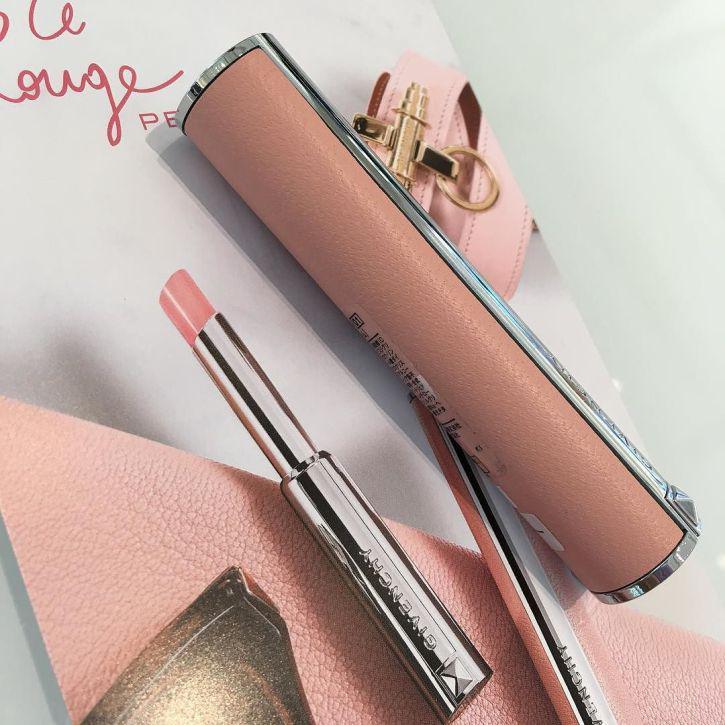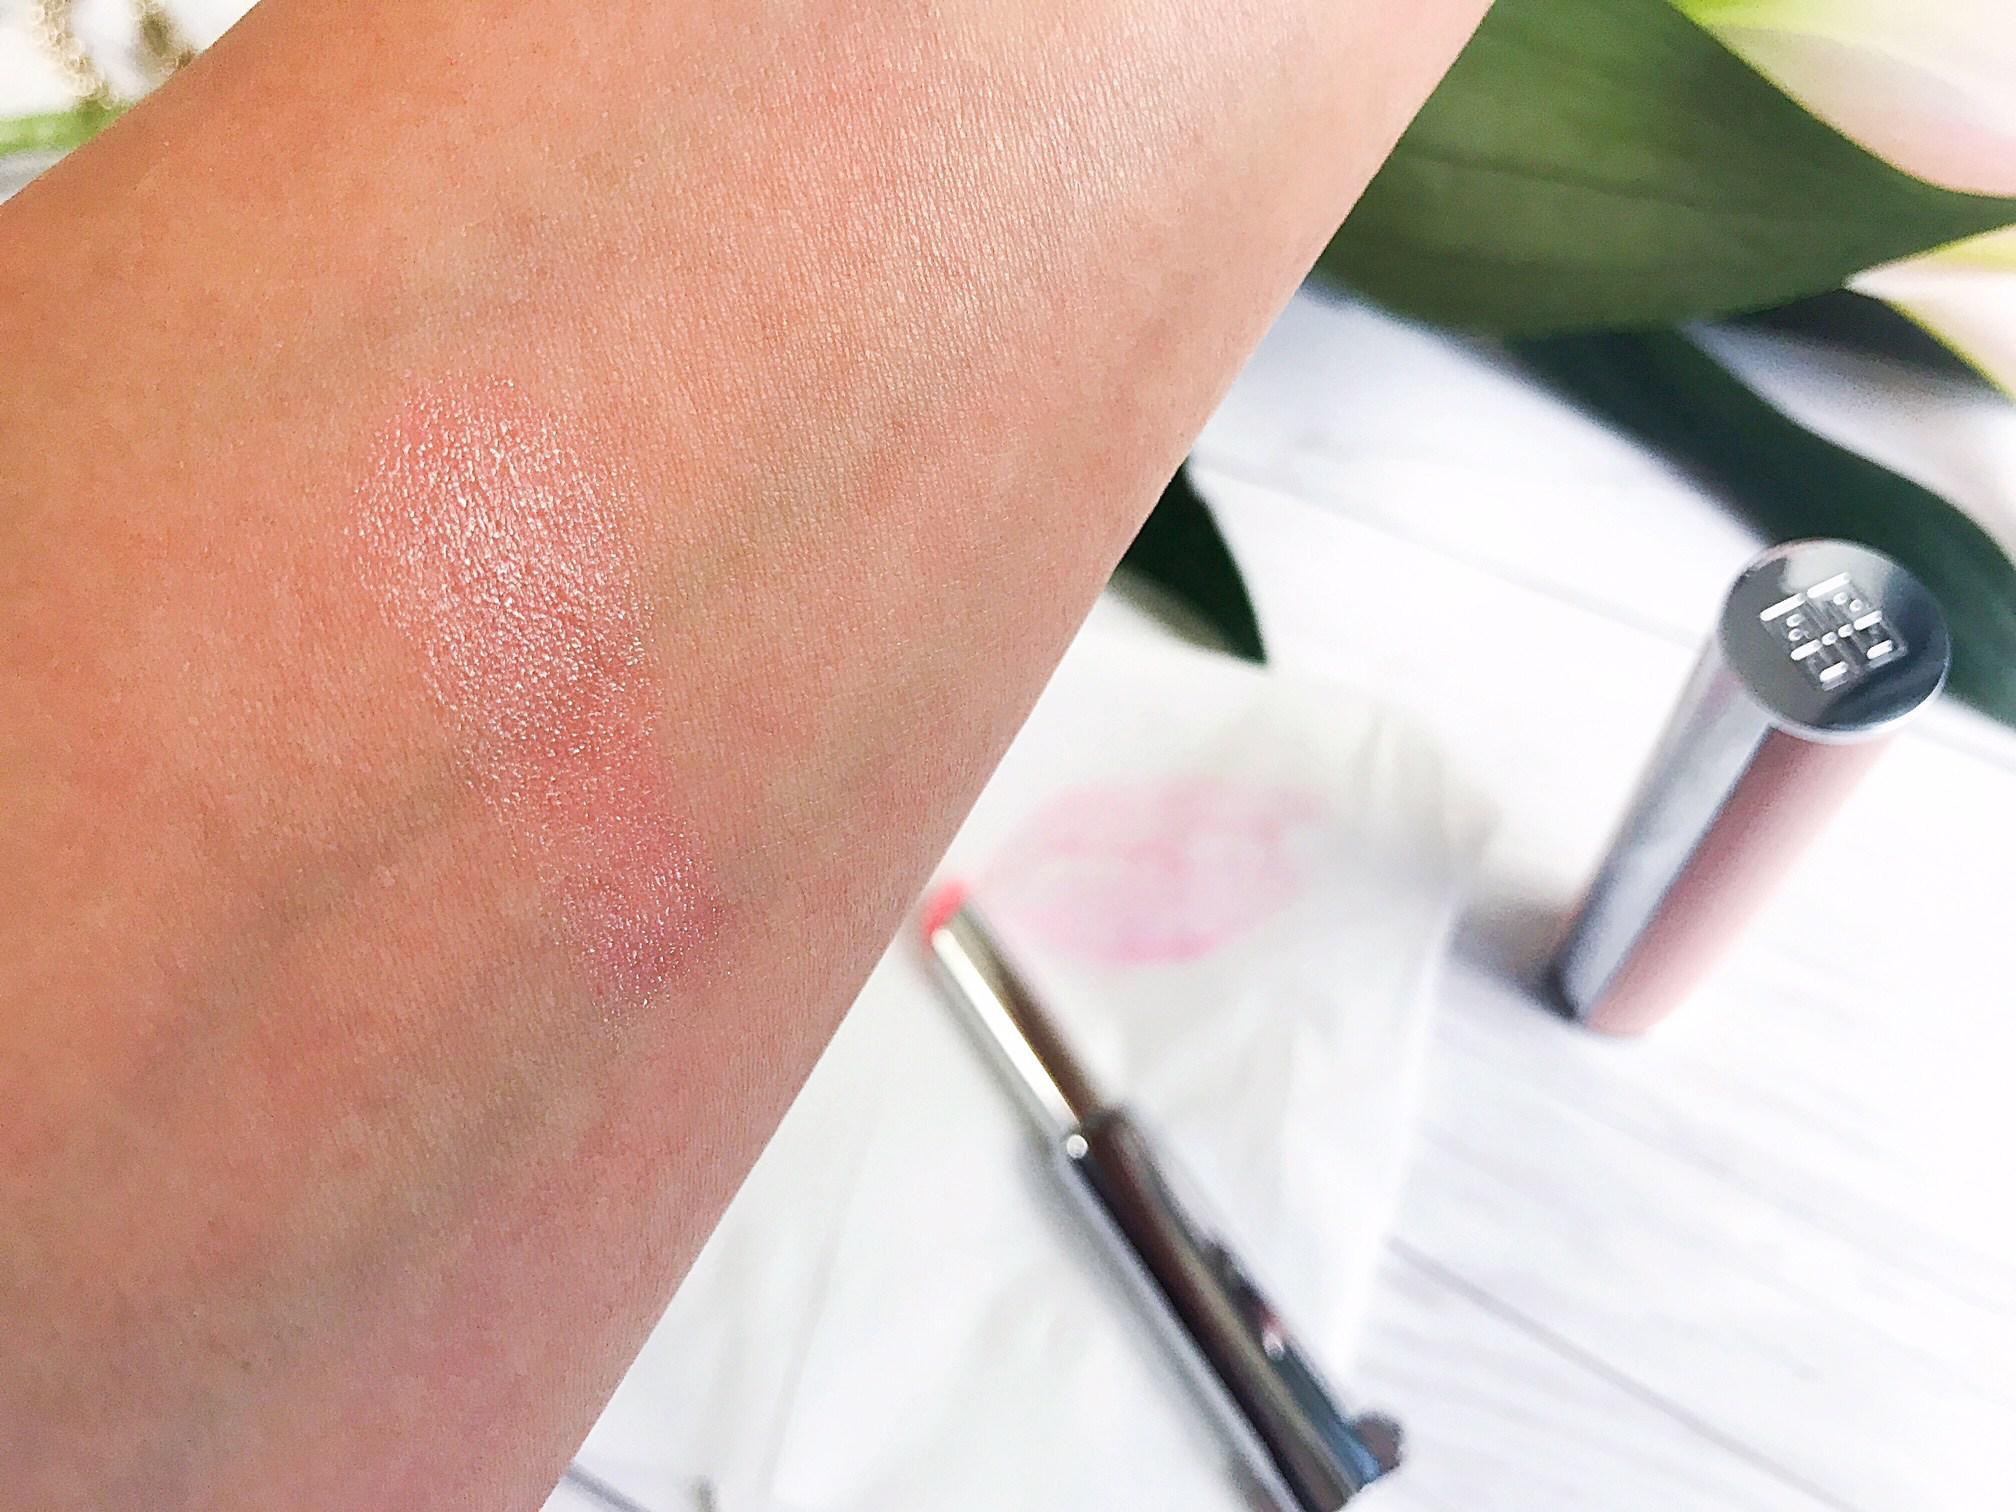The first image is the image on the left, the second image is the image on the right. Evaluate the accuracy of this statement regarding the images: "Each image shows an arm comparing the shades of at least two lipstick colors.". Is it true? Answer yes or no. No. The first image is the image on the left, the second image is the image on the right. Examine the images to the left and right. Is the description "The left image shows skin with two lipstick stripes on it, and the right image shows the top of a hand with three lipstick stripes." accurate? Answer yes or no. No. 